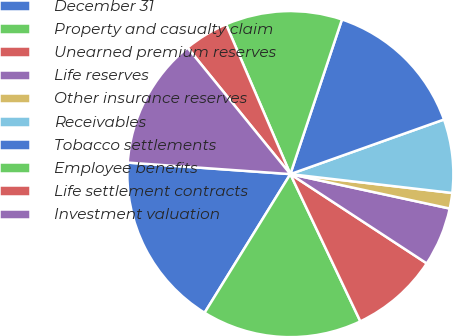Convert chart to OTSL. <chart><loc_0><loc_0><loc_500><loc_500><pie_chart><fcel>December 31<fcel>Property and casualty claim<fcel>Unearned premium reserves<fcel>Life reserves<fcel>Other insurance reserves<fcel>Receivables<fcel>Tobacco settlements<fcel>Employee benefits<fcel>Life settlement contracts<fcel>Investment valuation<nl><fcel>17.31%<fcel>15.88%<fcel>8.71%<fcel>5.84%<fcel>1.54%<fcel>7.28%<fcel>14.44%<fcel>11.58%<fcel>4.41%<fcel>13.01%<nl></chart> 